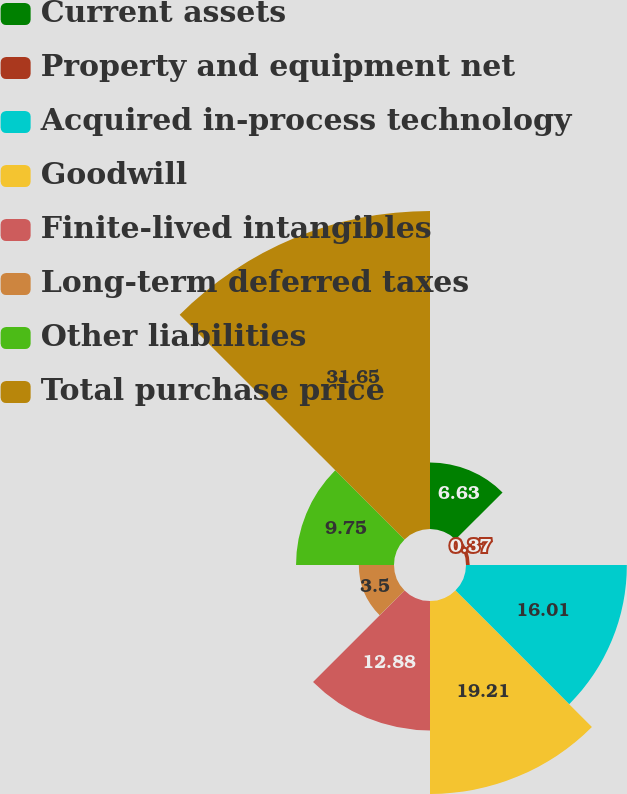Convert chart to OTSL. <chart><loc_0><loc_0><loc_500><loc_500><pie_chart><fcel>Current assets<fcel>Property and equipment net<fcel>Acquired in-process technology<fcel>Goodwill<fcel>Finite-lived intangibles<fcel>Long-term deferred taxes<fcel>Other liabilities<fcel>Total purchase price<nl><fcel>6.63%<fcel>0.37%<fcel>16.01%<fcel>19.21%<fcel>12.88%<fcel>3.5%<fcel>9.75%<fcel>31.65%<nl></chart> 